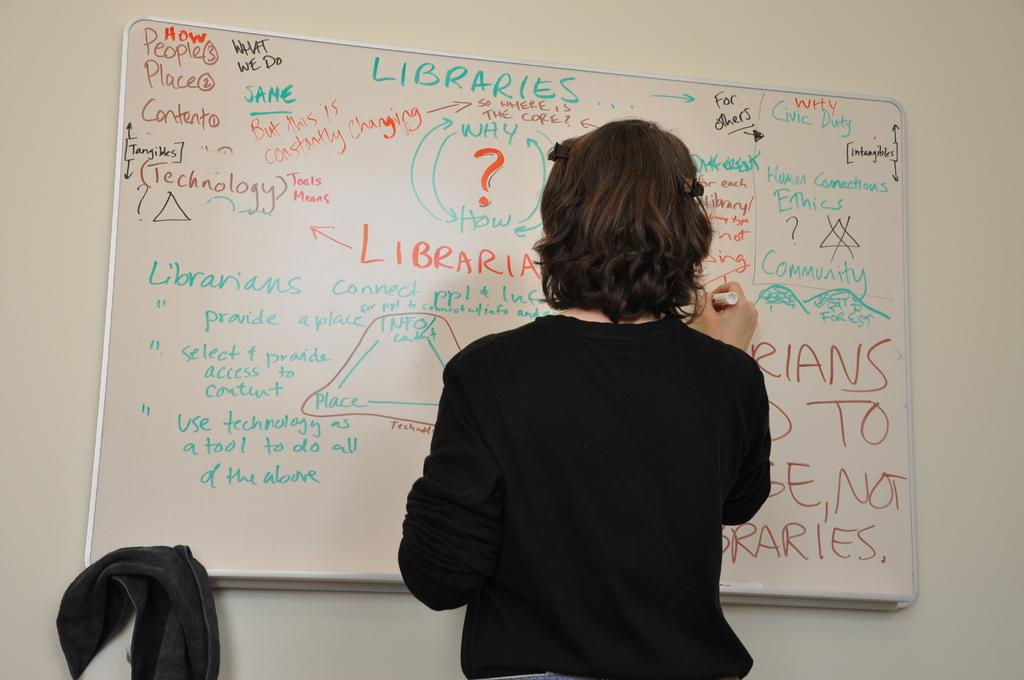<image>
Render a clear and concise summary of the photo. A woman writes on a board that says libraries at the top. 